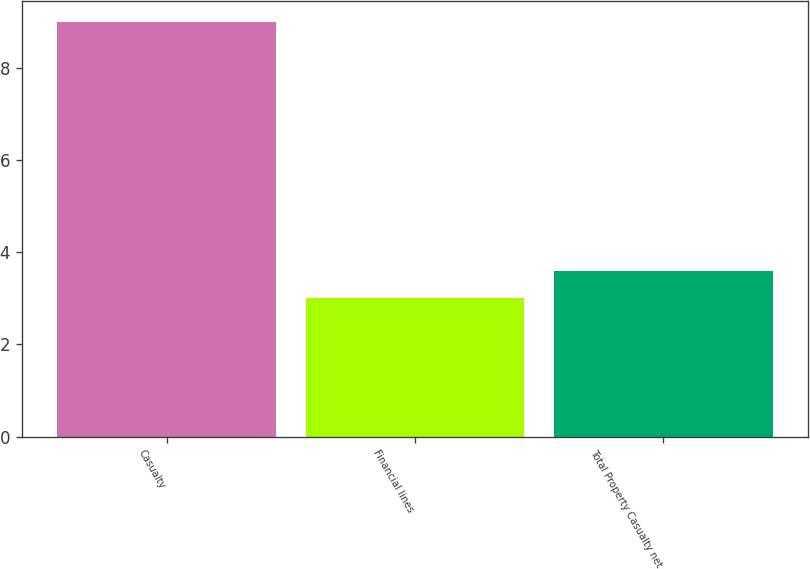Convert chart to OTSL. <chart><loc_0><loc_0><loc_500><loc_500><bar_chart><fcel>Casualty<fcel>Financial lines<fcel>Total Property Casualty net<nl><fcel>9<fcel>3<fcel>3.6<nl></chart> 